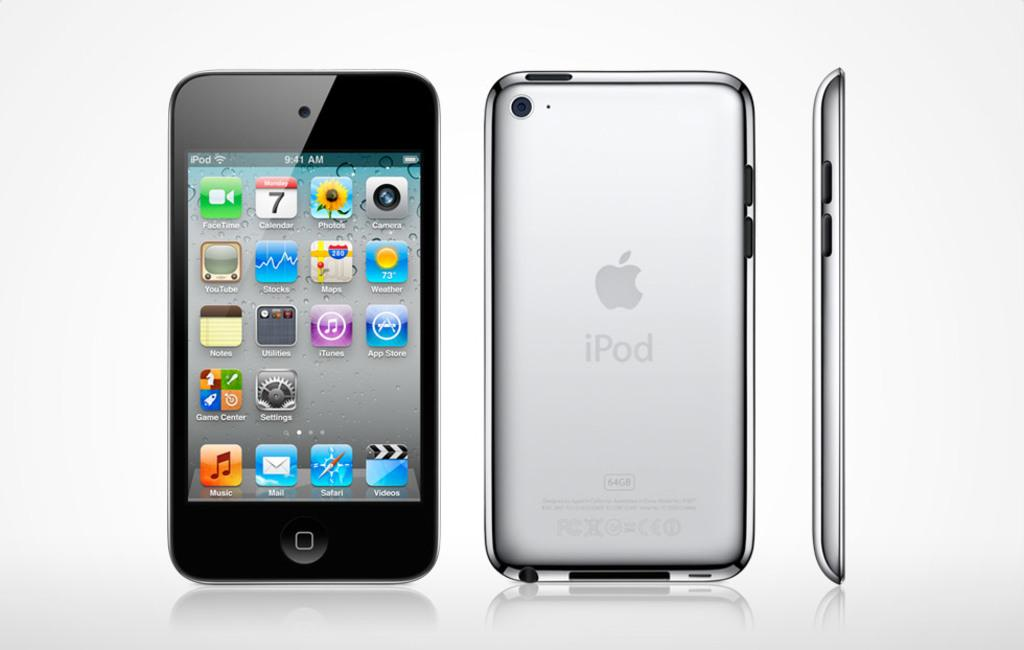Provide a one-sentence caption for the provided image. iPod homescreen with a host of apps such as face time and photos. 